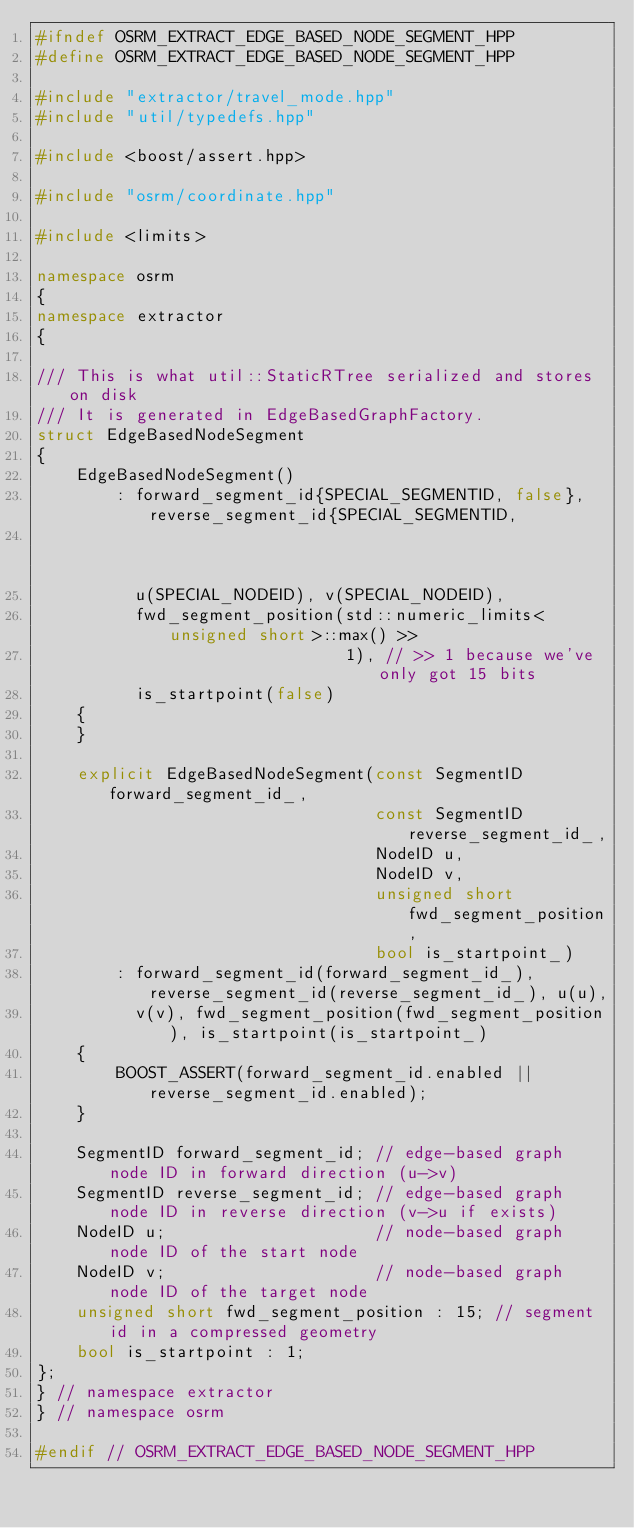<code> <loc_0><loc_0><loc_500><loc_500><_C++_>#ifndef OSRM_EXTRACT_EDGE_BASED_NODE_SEGMENT_HPP
#define OSRM_EXTRACT_EDGE_BASED_NODE_SEGMENT_HPP

#include "extractor/travel_mode.hpp"
#include "util/typedefs.hpp"

#include <boost/assert.hpp>

#include "osrm/coordinate.hpp"

#include <limits>

namespace osrm
{
namespace extractor
{

/// This is what util::StaticRTree serialized and stores on disk
/// It is generated in EdgeBasedGraphFactory.
struct EdgeBasedNodeSegment
{
    EdgeBasedNodeSegment()
        : forward_segment_id{SPECIAL_SEGMENTID, false}, reverse_segment_id{SPECIAL_SEGMENTID,
                                                                           false},
          u(SPECIAL_NODEID), v(SPECIAL_NODEID),
          fwd_segment_position(std::numeric_limits<unsigned short>::max() >>
                               1), // >> 1 because we've only got 15 bits
          is_startpoint(false)
    {
    }

    explicit EdgeBasedNodeSegment(const SegmentID forward_segment_id_,
                                  const SegmentID reverse_segment_id_,
                                  NodeID u,
                                  NodeID v,
                                  unsigned short fwd_segment_position,
                                  bool is_startpoint_)
        : forward_segment_id(forward_segment_id_), reverse_segment_id(reverse_segment_id_), u(u),
          v(v), fwd_segment_position(fwd_segment_position), is_startpoint(is_startpoint_)
    {
        BOOST_ASSERT(forward_segment_id.enabled || reverse_segment_id.enabled);
    }

    SegmentID forward_segment_id; // edge-based graph node ID in forward direction (u->v)
    SegmentID reverse_segment_id; // edge-based graph node ID in reverse direction (v->u if exists)
    NodeID u;                     // node-based graph node ID of the start node
    NodeID v;                     // node-based graph node ID of the target node
    unsigned short fwd_segment_position : 15; // segment id in a compressed geometry
    bool is_startpoint : 1;
};
} // namespace extractor
} // namespace osrm

#endif // OSRM_EXTRACT_EDGE_BASED_NODE_SEGMENT_HPP
</code> 